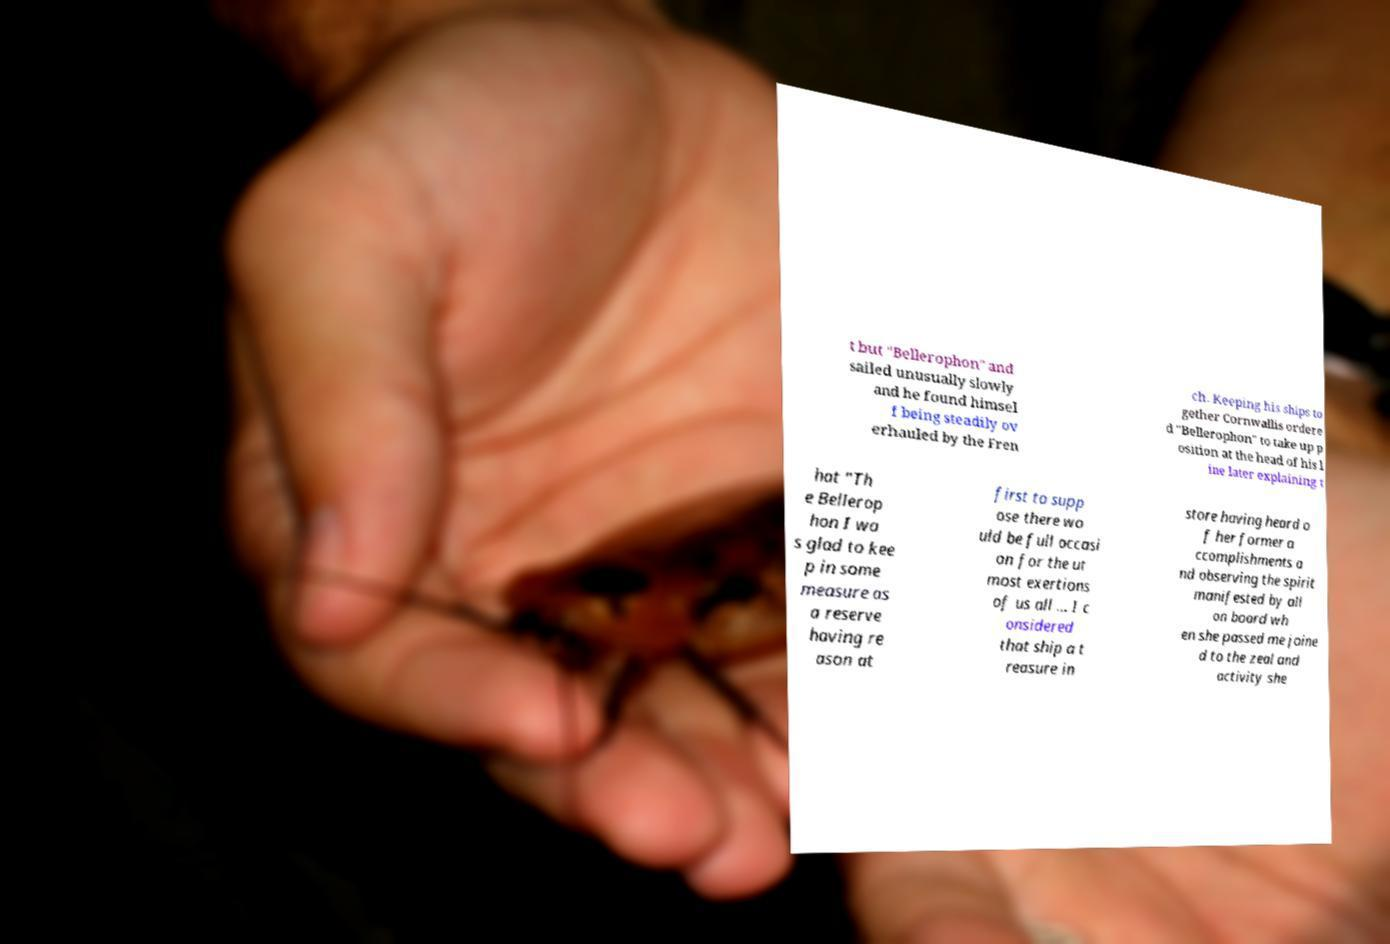What messages or text are displayed in this image? I need them in a readable, typed format. t but "Bellerophon" and sailed unusually slowly and he found himsel f being steadily ov erhauled by the Fren ch. Keeping his ships to gether Cornwallis ordere d "Bellerophon" to take up p osition at the head of his l ine later explaining t hat "Th e Bellerop hon I wa s glad to kee p in some measure as a reserve having re ason at first to supp ose there wo uld be full occasi on for the ut most exertions of us all ... I c onsidered that ship a t reasure in store having heard o f her former a ccomplishments a nd observing the spirit manifested by all on board wh en she passed me joine d to the zeal and activity she 